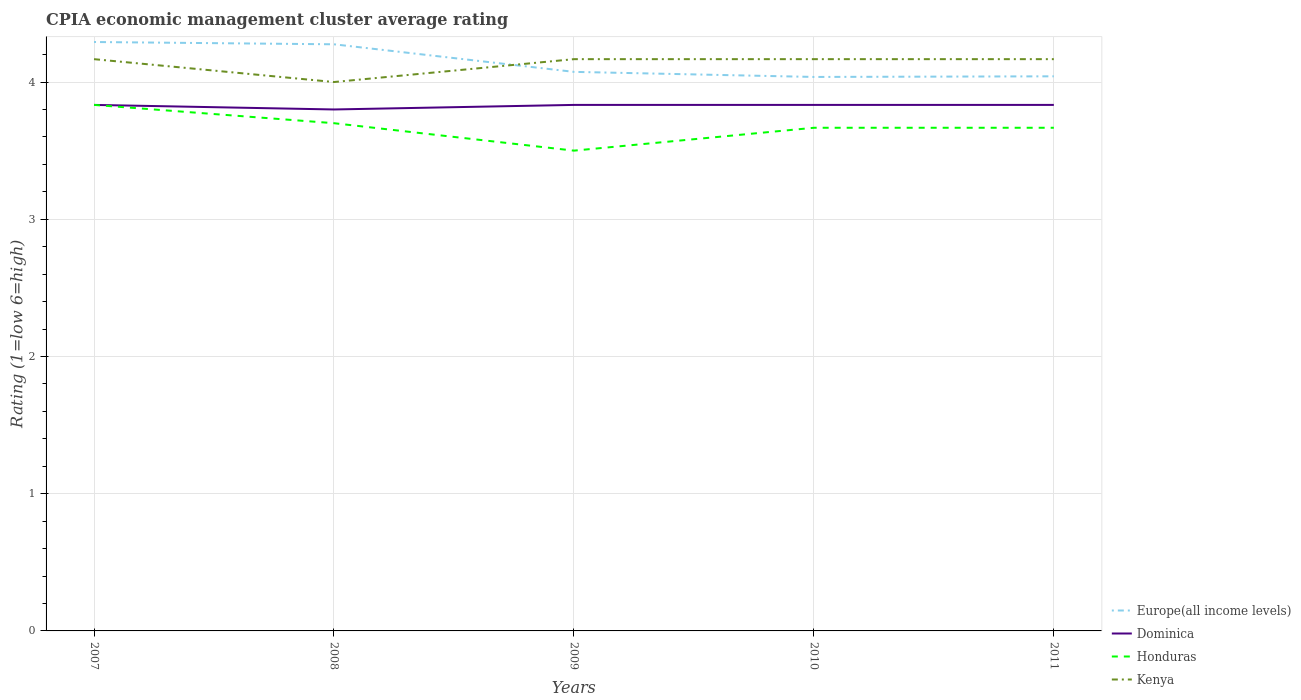What is the total CPIA rating in Europe(all income levels) in the graph?
Ensure brevity in your answer.  0.02. What is the difference between the highest and the second highest CPIA rating in Kenya?
Provide a short and direct response. 0.17. How many lines are there?
Make the answer very short. 4. How many years are there in the graph?
Offer a very short reply. 5. What is the difference between two consecutive major ticks on the Y-axis?
Provide a short and direct response. 1. Are the values on the major ticks of Y-axis written in scientific E-notation?
Give a very brief answer. No. Does the graph contain grids?
Your answer should be very brief. Yes. How many legend labels are there?
Keep it short and to the point. 4. What is the title of the graph?
Offer a terse response. CPIA economic management cluster average rating. Does "Belarus" appear as one of the legend labels in the graph?
Provide a short and direct response. No. What is the Rating (1=low 6=high) in Europe(all income levels) in 2007?
Your answer should be very brief. 4.29. What is the Rating (1=low 6=high) of Dominica in 2007?
Offer a very short reply. 3.83. What is the Rating (1=low 6=high) of Honduras in 2007?
Keep it short and to the point. 3.83. What is the Rating (1=low 6=high) in Kenya in 2007?
Make the answer very short. 4.17. What is the Rating (1=low 6=high) in Europe(all income levels) in 2008?
Your answer should be compact. 4.28. What is the Rating (1=low 6=high) of Honduras in 2008?
Provide a short and direct response. 3.7. What is the Rating (1=low 6=high) in Kenya in 2008?
Provide a short and direct response. 4. What is the Rating (1=low 6=high) in Europe(all income levels) in 2009?
Make the answer very short. 4.07. What is the Rating (1=low 6=high) of Dominica in 2009?
Provide a short and direct response. 3.83. What is the Rating (1=low 6=high) of Kenya in 2009?
Your answer should be compact. 4.17. What is the Rating (1=low 6=high) of Europe(all income levels) in 2010?
Offer a very short reply. 4.04. What is the Rating (1=low 6=high) in Dominica in 2010?
Your answer should be compact. 3.83. What is the Rating (1=low 6=high) in Honduras in 2010?
Make the answer very short. 3.67. What is the Rating (1=low 6=high) of Kenya in 2010?
Provide a succinct answer. 4.17. What is the Rating (1=low 6=high) in Europe(all income levels) in 2011?
Offer a very short reply. 4.04. What is the Rating (1=low 6=high) of Dominica in 2011?
Offer a very short reply. 3.83. What is the Rating (1=low 6=high) in Honduras in 2011?
Your answer should be very brief. 3.67. What is the Rating (1=low 6=high) of Kenya in 2011?
Your response must be concise. 4.17. Across all years, what is the maximum Rating (1=low 6=high) of Europe(all income levels)?
Ensure brevity in your answer.  4.29. Across all years, what is the maximum Rating (1=low 6=high) of Dominica?
Your response must be concise. 3.83. Across all years, what is the maximum Rating (1=low 6=high) of Honduras?
Your answer should be compact. 3.83. Across all years, what is the maximum Rating (1=low 6=high) in Kenya?
Ensure brevity in your answer.  4.17. Across all years, what is the minimum Rating (1=low 6=high) of Europe(all income levels)?
Keep it short and to the point. 4.04. What is the total Rating (1=low 6=high) in Europe(all income levels) in the graph?
Make the answer very short. 20.72. What is the total Rating (1=low 6=high) of Dominica in the graph?
Your response must be concise. 19.13. What is the total Rating (1=low 6=high) in Honduras in the graph?
Provide a short and direct response. 18.37. What is the total Rating (1=low 6=high) in Kenya in the graph?
Make the answer very short. 20.67. What is the difference between the Rating (1=low 6=high) of Europe(all income levels) in 2007 and that in 2008?
Ensure brevity in your answer.  0.02. What is the difference between the Rating (1=low 6=high) in Honduras in 2007 and that in 2008?
Give a very brief answer. 0.13. What is the difference between the Rating (1=low 6=high) in Europe(all income levels) in 2007 and that in 2009?
Provide a short and direct response. 0.22. What is the difference between the Rating (1=low 6=high) of Dominica in 2007 and that in 2009?
Give a very brief answer. 0. What is the difference between the Rating (1=low 6=high) in Kenya in 2007 and that in 2009?
Give a very brief answer. 0. What is the difference between the Rating (1=low 6=high) in Europe(all income levels) in 2007 and that in 2010?
Your response must be concise. 0.25. What is the difference between the Rating (1=low 6=high) in Dominica in 2007 and that in 2010?
Make the answer very short. 0. What is the difference between the Rating (1=low 6=high) of Kenya in 2007 and that in 2010?
Your answer should be very brief. 0. What is the difference between the Rating (1=low 6=high) of Dominica in 2007 and that in 2011?
Provide a succinct answer. 0. What is the difference between the Rating (1=low 6=high) in Honduras in 2007 and that in 2011?
Keep it short and to the point. 0.17. What is the difference between the Rating (1=low 6=high) in Europe(all income levels) in 2008 and that in 2009?
Make the answer very short. 0.2. What is the difference between the Rating (1=low 6=high) in Dominica in 2008 and that in 2009?
Make the answer very short. -0.03. What is the difference between the Rating (1=low 6=high) of Europe(all income levels) in 2008 and that in 2010?
Give a very brief answer. 0.24. What is the difference between the Rating (1=low 6=high) in Dominica in 2008 and that in 2010?
Your response must be concise. -0.03. What is the difference between the Rating (1=low 6=high) of Honduras in 2008 and that in 2010?
Offer a very short reply. 0.03. What is the difference between the Rating (1=low 6=high) of Europe(all income levels) in 2008 and that in 2011?
Keep it short and to the point. 0.23. What is the difference between the Rating (1=low 6=high) in Dominica in 2008 and that in 2011?
Your answer should be compact. -0.03. What is the difference between the Rating (1=low 6=high) of Kenya in 2008 and that in 2011?
Give a very brief answer. -0.17. What is the difference between the Rating (1=low 6=high) in Europe(all income levels) in 2009 and that in 2010?
Your answer should be compact. 0.04. What is the difference between the Rating (1=low 6=high) in Honduras in 2009 and that in 2010?
Offer a very short reply. -0.17. What is the difference between the Rating (1=low 6=high) of Europe(all income levels) in 2009 and that in 2011?
Your answer should be compact. 0.03. What is the difference between the Rating (1=low 6=high) of Honduras in 2009 and that in 2011?
Your answer should be compact. -0.17. What is the difference between the Rating (1=low 6=high) in Europe(all income levels) in 2010 and that in 2011?
Offer a very short reply. -0. What is the difference between the Rating (1=low 6=high) in Dominica in 2010 and that in 2011?
Keep it short and to the point. 0. What is the difference between the Rating (1=low 6=high) of Honduras in 2010 and that in 2011?
Offer a very short reply. 0. What is the difference between the Rating (1=low 6=high) of Europe(all income levels) in 2007 and the Rating (1=low 6=high) of Dominica in 2008?
Offer a very short reply. 0.49. What is the difference between the Rating (1=low 6=high) of Europe(all income levels) in 2007 and the Rating (1=low 6=high) of Honduras in 2008?
Your response must be concise. 0.59. What is the difference between the Rating (1=low 6=high) of Europe(all income levels) in 2007 and the Rating (1=low 6=high) of Kenya in 2008?
Ensure brevity in your answer.  0.29. What is the difference between the Rating (1=low 6=high) of Dominica in 2007 and the Rating (1=low 6=high) of Honduras in 2008?
Your answer should be very brief. 0.13. What is the difference between the Rating (1=low 6=high) of Dominica in 2007 and the Rating (1=low 6=high) of Kenya in 2008?
Keep it short and to the point. -0.17. What is the difference between the Rating (1=low 6=high) in Honduras in 2007 and the Rating (1=low 6=high) in Kenya in 2008?
Ensure brevity in your answer.  -0.17. What is the difference between the Rating (1=low 6=high) of Europe(all income levels) in 2007 and the Rating (1=low 6=high) of Dominica in 2009?
Keep it short and to the point. 0.46. What is the difference between the Rating (1=low 6=high) in Europe(all income levels) in 2007 and the Rating (1=low 6=high) in Honduras in 2009?
Offer a very short reply. 0.79. What is the difference between the Rating (1=low 6=high) in Honduras in 2007 and the Rating (1=low 6=high) in Kenya in 2009?
Offer a very short reply. -0.33. What is the difference between the Rating (1=low 6=high) in Europe(all income levels) in 2007 and the Rating (1=low 6=high) in Dominica in 2010?
Ensure brevity in your answer.  0.46. What is the difference between the Rating (1=low 6=high) of Europe(all income levels) in 2007 and the Rating (1=low 6=high) of Honduras in 2010?
Ensure brevity in your answer.  0.62. What is the difference between the Rating (1=low 6=high) in Europe(all income levels) in 2007 and the Rating (1=low 6=high) in Dominica in 2011?
Ensure brevity in your answer.  0.46. What is the difference between the Rating (1=low 6=high) in Europe(all income levels) in 2007 and the Rating (1=low 6=high) in Honduras in 2011?
Your response must be concise. 0.62. What is the difference between the Rating (1=low 6=high) of Europe(all income levels) in 2007 and the Rating (1=low 6=high) of Kenya in 2011?
Your answer should be very brief. 0.12. What is the difference between the Rating (1=low 6=high) of Europe(all income levels) in 2008 and the Rating (1=low 6=high) of Dominica in 2009?
Your response must be concise. 0.44. What is the difference between the Rating (1=low 6=high) in Europe(all income levels) in 2008 and the Rating (1=low 6=high) in Honduras in 2009?
Provide a succinct answer. 0.78. What is the difference between the Rating (1=low 6=high) of Europe(all income levels) in 2008 and the Rating (1=low 6=high) of Kenya in 2009?
Keep it short and to the point. 0.11. What is the difference between the Rating (1=low 6=high) of Dominica in 2008 and the Rating (1=low 6=high) of Honduras in 2009?
Give a very brief answer. 0.3. What is the difference between the Rating (1=low 6=high) of Dominica in 2008 and the Rating (1=low 6=high) of Kenya in 2009?
Make the answer very short. -0.37. What is the difference between the Rating (1=low 6=high) in Honduras in 2008 and the Rating (1=low 6=high) in Kenya in 2009?
Ensure brevity in your answer.  -0.47. What is the difference between the Rating (1=low 6=high) in Europe(all income levels) in 2008 and the Rating (1=low 6=high) in Dominica in 2010?
Keep it short and to the point. 0.44. What is the difference between the Rating (1=low 6=high) of Europe(all income levels) in 2008 and the Rating (1=low 6=high) of Honduras in 2010?
Provide a succinct answer. 0.61. What is the difference between the Rating (1=low 6=high) in Europe(all income levels) in 2008 and the Rating (1=low 6=high) in Kenya in 2010?
Your response must be concise. 0.11. What is the difference between the Rating (1=low 6=high) of Dominica in 2008 and the Rating (1=low 6=high) of Honduras in 2010?
Provide a short and direct response. 0.13. What is the difference between the Rating (1=low 6=high) of Dominica in 2008 and the Rating (1=low 6=high) of Kenya in 2010?
Provide a succinct answer. -0.37. What is the difference between the Rating (1=low 6=high) of Honduras in 2008 and the Rating (1=low 6=high) of Kenya in 2010?
Ensure brevity in your answer.  -0.47. What is the difference between the Rating (1=low 6=high) in Europe(all income levels) in 2008 and the Rating (1=low 6=high) in Dominica in 2011?
Provide a succinct answer. 0.44. What is the difference between the Rating (1=low 6=high) of Europe(all income levels) in 2008 and the Rating (1=low 6=high) of Honduras in 2011?
Ensure brevity in your answer.  0.61. What is the difference between the Rating (1=low 6=high) of Europe(all income levels) in 2008 and the Rating (1=low 6=high) of Kenya in 2011?
Offer a very short reply. 0.11. What is the difference between the Rating (1=low 6=high) of Dominica in 2008 and the Rating (1=low 6=high) of Honduras in 2011?
Offer a very short reply. 0.13. What is the difference between the Rating (1=low 6=high) in Dominica in 2008 and the Rating (1=low 6=high) in Kenya in 2011?
Provide a succinct answer. -0.37. What is the difference between the Rating (1=low 6=high) of Honduras in 2008 and the Rating (1=low 6=high) of Kenya in 2011?
Make the answer very short. -0.47. What is the difference between the Rating (1=low 6=high) in Europe(all income levels) in 2009 and the Rating (1=low 6=high) in Dominica in 2010?
Offer a terse response. 0.24. What is the difference between the Rating (1=low 6=high) in Europe(all income levels) in 2009 and the Rating (1=low 6=high) in Honduras in 2010?
Provide a succinct answer. 0.41. What is the difference between the Rating (1=low 6=high) of Europe(all income levels) in 2009 and the Rating (1=low 6=high) of Kenya in 2010?
Your answer should be compact. -0.09. What is the difference between the Rating (1=low 6=high) in Dominica in 2009 and the Rating (1=low 6=high) in Honduras in 2010?
Offer a terse response. 0.17. What is the difference between the Rating (1=low 6=high) in Dominica in 2009 and the Rating (1=low 6=high) in Kenya in 2010?
Make the answer very short. -0.33. What is the difference between the Rating (1=low 6=high) of Europe(all income levels) in 2009 and the Rating (1=low 6=high) of Dominica in 2011?
Your answer should be very brief. 0.24. What is the difference between the Rating (1=low 6=high) of Europe(all income levels) in 2009 and the Rating (1=low 6=high) of Honduras in 2011?
Provide a short and direct response. 0.41. What is the difference between the Rating (1=low 6=high) in Europe(all income levels) in 2009 and the Rating (1=low 6=high) in Kenya in 2011?
Provide a short and direct response. -0.09. What is the difference between the Rating (1=low 6=high) in Europe(all income levels) in 2010 and the Rating (1=low 6=high) in Dominica in 2011?
Provide a short and direct response. 0.2. What is the difference between the Rating (1=low 6=high) of Europe(all income levels) in 2010 and the Rating (1=low 6=high) of Honduras in 2011?
Offer a terse response. 0.37. What is the difference between the Rating (1=low 6=high) in Europe(all income levels) in 2010 and the Rating (1=low 6=high) in Kenya in 2011?
Provide a short and direct response. -0.13. What is the difference between the Rating (1=low 6=high) in Dominica in 2010 and the Rating (1=low 6=high) in Honduras in 2011?
Your response must be concise. 0.17. What is the average Rating (1=low 6=high) of Europe(all income levels) per year?
Ensure brevity in your answer.  4.14. What is the average Rating (1=low 6=high) in Dominica per year?
Keep it short and to the point. 3.83. What is the average Rating (1=low 6=high) of Honduras per year?
Make the answer very short. 3.67. What is the average Rating (1=low 6=high) of Kenya per year?
Your answer should be compact. 4.13. In the year 2007, what is the difference between the Rating (1=low 6=high) of Europe(all income levels) and Rating (1=low 6=high) of Dominica?
Provide a short and direct response. 0.46. In the year 2007, what is the difference between the Rating (1=low 6=high) of Europe(all income levels) and Rating (1=low 6=high) of Honduras?
Your answer should be very brief. 0.46. In the year 2007, what is the difference between the Rating (1=low 6=high) in Dominica and Rating (1=low 6=high) in Honduras?
Give a very brief answer. 0. In the year 2008, what is the difference between the Rating (1=low 6=high) of Europe(all income levels) and Rating (1=low 6=high) of Dominica?
Ensure brevity in your answer.  0.47. In the year 2008, what is the difference between the Rating (1=low 6=high) of Europe(all income levels) and Rating (1=low 6=high) of Honduras?
Give a very brief answer. 0.57. In the year 2008, what is the difference between the Rating (1=low 6=high) of Europe(all income levels) and Rating (1=low 6=high) of Kenya?
Provide a short and direct response. 0.28. In the year 2008, what is the difference between the Rating (1=low 6=high) in Dominica and Rating (1=low 6=high) in Kenya?
Make the answer very short. -0.2. In the year 2008, what is the difference between the Rating (1=low 6=high) in Honduras and Rating (1=low 6=high) in Kenya?
Your answer should be very brief. -0.3. In the year 2009, what is the difference between the Rating (1=low 6=high) in Europe(all income levels) and Rating (1=low 6=high) in Dominica?
Your answer should be very brief. 0.24. In the year 2009, what is the difference between the Rating (1=low 6=high) in Europe(all income levels) and Rating (1=low 6=high) in Honduras?
Your answer should be compact. 0.57. In the year 2009, what is the difference between the Rating (1=low 6=high) in Europe(all income levels) and Rating (1=low 6=high) in Kenya?
Your answer should be very brief. -0.09. In the year 2009, what is the difference between the Rating (1=low 6=high) in Dominica and Rating (1=low 6=high) in Honduras?
Provide a short and direct response. 0.33. In the year 2009, what is the difference between the Rating (1=low 6=high) of Dominica and Rating (1=low 6=high) of Kenya?
Make the answer very short. -0.33. In the year 2010, what is the difference between the Rating (1=low 6=high) in Europe(all income levels) and Rating (1=low 6=high) in Dominica?
Offer a very short reply. 0.2. In the year 2010, what is the difference between the Rating (1=low 6=high) in Europe(all income levels) and Rating (1=low 6=high) in Honduras?
Offer a very short reply. 0.37. In the year 2010, what is the difference between the Rating (1=low 6=high) of Europe(all income levels) and Rating (1=low 6=high) of Kenya?
Give a very brief answer. -0.13. In the year 2011, what is the difference between the Rating (1=low 6=high) of Europe(all income levels) and Rating (1=low 6=high) of Dominica?
Ensure brevity in your answer.  0.21. In the year 2011, what is the difference between the Rating (1=low 6=high) of Europe(all income levels) and Rating (1=low 6=high) of Honduras?
Your answer should be compact. 0.38. In the year 2011, what is the difference between the Rating (1=low 6=high) in Europe(all income levels) and Rating (1=low 6=high) in Kenya?
Offer a terse response. -0.12. In the year 2011, what is the difference between the Rating (1=low 6=high) of Dominica and Rating (1=low 6=high) of Honduras?
Offer a terse response. 0.17. In the year 2011, what is the difference between the Rating (1=low 6=high) in Dominica and Rating (1=low 6=high) in Kenya?
Your answer should be compact. -0.33. What is the ratio of the Rating (1=low 6=high) of Dominica in 2007 to that in 2008?
Your response must be concise. 1.01. What is the ratio of the Rating (1=low 6=high) in Honduras in 2007 to that in 2008?
Provide a succinct answer. 1.04. What is the ratio of the Rating (1=low 6=high) in Kenya in 2007 to that in 2008?
Your answer should be very brief. 1.04. What is the ratio of the Rating (1=low 6=high) of Europe(all income levels) in 2007 to that in 2009?
Ensure brevity in your answer.  1.05. What is the ratio of the Rating (1=low 6=high) of Dominica in 2007 to that in 2009?
Ensure brevity in your answer.  1. What is the ratio of the Rating (1=low 6=high) in Honduras in 2007 to that in 2009?
Your answer should be compact. 1.1. What is the ratio of the Rating (1=low 6=high) in Kenya in 2007 to that in 2009?
Your response must be concise. 1. What is the ratio of the Rating (1=low 6=high) in Europe(all income levels) in 2007 to that in 2010?
Your answer should be very brief. 1.06. What is the ratio of the Rating (1=low 6=high) in Honduras in 2007 to that in 2010?
Make the answer very short. 1.05. What is the ratio of the Rating (1=low 6=high) in Kenya in 2007 to that in 2010?
Ensure brevity in your answer.  1. What is the ratio of the Rating (1=low 6=high) of Europe(all income levels) in 2007 to that in 2011?
Provide a short and direct response. 1.06. What is the ratio of the Rating (1=low 6=high) of Dominica in 2007 to that in 2011?
Offer a very short reply. 1. What is the ratio of the Rating (1=low 6=high) in Honduras in 2007 to that in 2011?
Provide a succinct answer. 1.05. What is the ratio of the Rating (1=low 6=high) in Europe(all income levels) in 2008 to that in 2009?
Ensure brevity in your answer.  1.05. What is the ratio of the Rating (1=low 6=high) in Dominica in 2008 to that in 2009?
Give a very brief answer. 0.99. What is the ratio of the Rating (1=low 6=high) of Honduras in 2008 to that in 2009?
Keep it short and to the point. 1.06. What is the ratio of the Rating (1=low 6=high) in Europe(all income levels) in 2008 to that in 2010?
Keep it short and to the point. 1.06. What is the ratio of the Rating (1=low 6=high) in Dominica in 2008 to that in 2010?
Offer a very short reply. 0.99. What is the ratio of the Rating (1=low 6=high) of Honduras in 2008 to that in 2010?
Give a very brief answer. 1.01. What is the ratio of the Rating (1=low 6=high) in Kenya in 2008 to that in 2010?
Your answer should be compact. 0.96. What is the ratio of the Rating (1=low 6=high) of Europe(all income levels) in 2008 to that in 2011?
Your response must be concise. 1.06. What is the ratio of the Rating (1=low 6=high) in Dominica in 2008 to that in 2011?
Provide a succinct answer. 0.99. What is the ratio of the Rating (1=low 6=high) in Honduras in 2008 to that in 2011?
Offer a very short reply. 1.01. What is the ratio of the Rating (1=low 6=high) in Europe(all income levels) in 2009 to that in 2010?
Give a very brief answer. 1.01. What is the ratio of the Rating (1=low 6=high) of Honduras in 2009 to that in 2010?
Your answer should be very brief. 0.95. What is the ratio of the Rating (1=low 6=high) of Honduras in 2009 to that in 2011?
Offer a terse response. 0.95. What is the ratio of the Rating (1=low 6=high) in Kenya in 2009 to that in 2011?
Your response must be concise. 1. What is the ratio of the Rating (1=low 6=high) of Europe(all income levels) in 2010 to that in 2011?
Make the answer very short. 1. What is the ratio of the Rating (1=low 6=high) of Honduras in 2010 to that in 2011?
Provide a short and direct response. 1. What is the difference between the highest and the second highest Rating (1=low 6=high) in Europe(all income levels)?
Keep it short and to the point. 0.02. What is the difference between the highest and the second highest Rating (1=low 6=high) of Honduras?
Your answer should be compact. 0.13. What is the difference between the highest and the lowest Rating (1=low 6=high) of Europe(all income levels)?
Offer a terse response. 0.25. What is the difference between the highest and the lowest Rating (1=low 6=high) of Dominica?
Offer a very short reply. 0.03. 